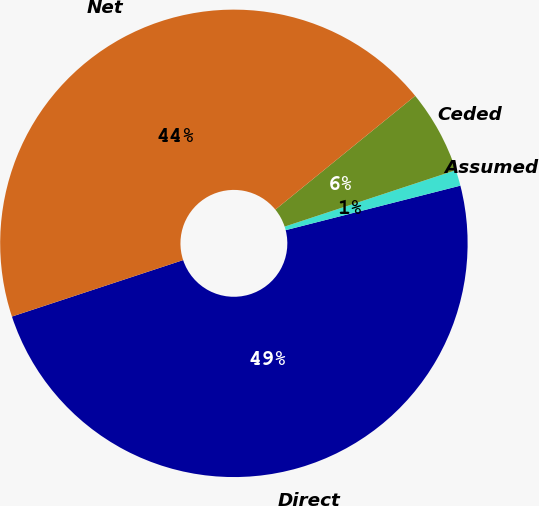<chart> <loc_0><loc_0><loc_500><loc_500><pie_chart><fcel>Direct<fcel>Assumed<fcel>Ceded<fcel>Net<nl><fcel>48.9%<fcel>1.1%<fcel>5.8%<fcel>44.2%<nl></chart> 